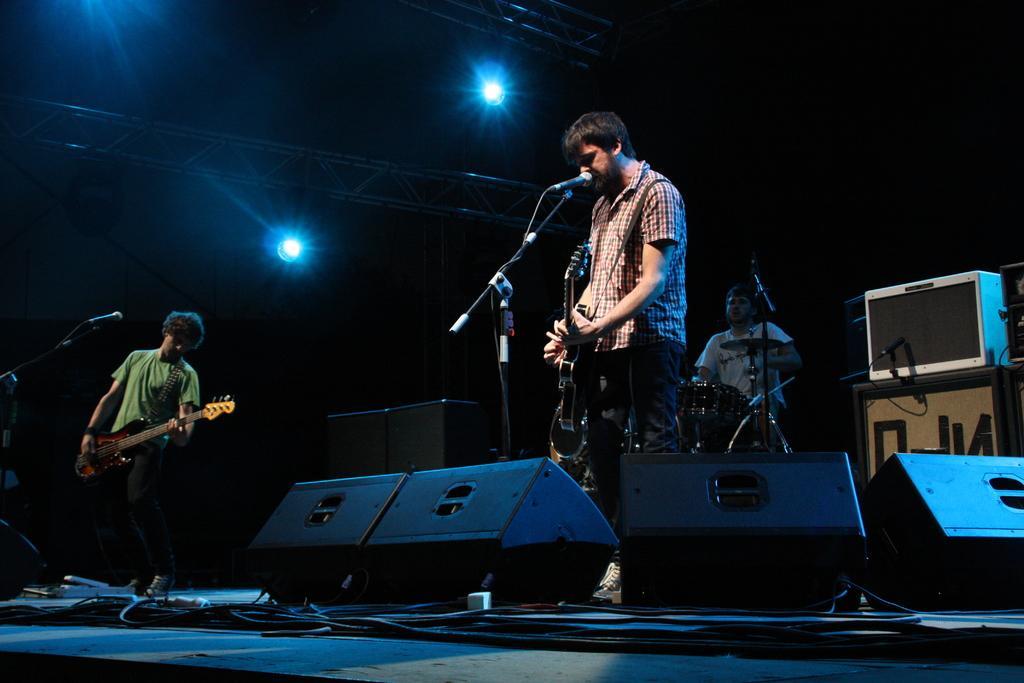How would you summarize this image in a sentence or two? On top there are focusing lights. This man is playing guitar and singing in-front of mic. This man is playing musical instruments. Far this man is also playing guitar. This is device. 